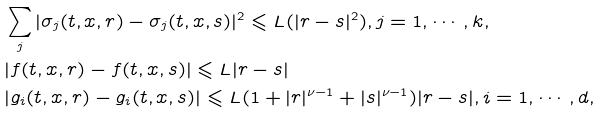Convert formula to latex. <formula><loc_0><loc_0><loc_500><loc_500>& \sum _ { j } | \sigma _ { j } ( t , x , r ) - \sigma _ { j } ( t , x , s ) | ^ { 2 } \leqslant L ( | r - s | ^ { 2 } ) , j = 1 , \cdots , k , \\ & | f ( t , x , r ) - f ( t , x , s ) | \leqslant L | r - s | \\ & | g _ { i } ( t , x , r ) - g _ { i } ( t , x , s ) | \leqslant L ( 1 + | r | ^ { \nu - 1 } + | s | ^ { \nu - 1 } ) | r - s | , i = 1 , \cdots , d ,</formula> 